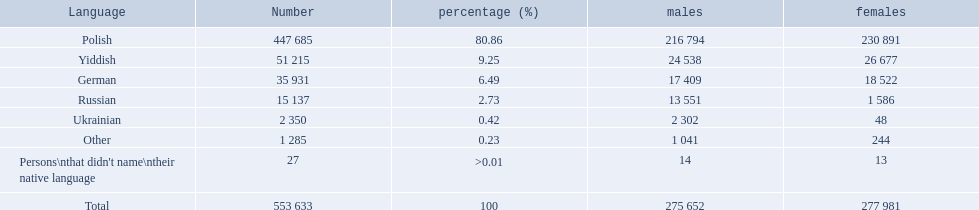What are the percentages of people? 80.86, 9.25, 6.49, 2.73, 0.42, 0.23, >0.01. Which language is .42%? Ukrainian. What were the languages in plock governorate? Polish, Yiddish, German, Russian, Ukrainian, Other. Which language has a value of .42? Ukrainian. What was the maximum percentage of a single language spoken in the plock governorate? 80.86. Which language was spoken by 80.86% of the population? Polish. 